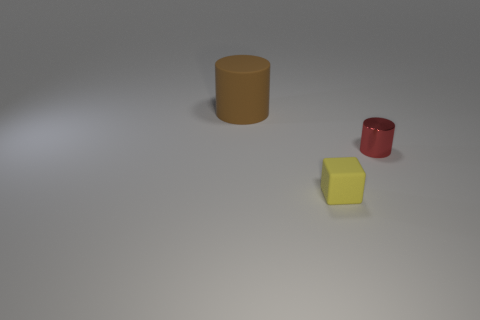Add 1 large cylinders. How many objects exist? 4 Subtract all cylinders. How many objects are left? 1 Subtract 0 red cubes. How many objects are left? 3 Subtract all large brown matte cylinders. Subtract all big cylinders. How many objects are left? 1 Add 2 brown cylinders. How many brown cylinders are left? 3 Add 3 tiny gray matte objects. How many tiny gray matte objects exist? 3 